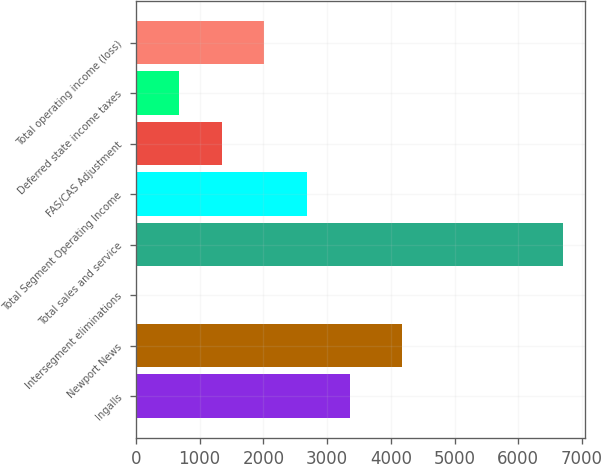<chart> <loc_0><loc_0><loc_500><loc_500><bar_chart><fcel>Ingalls<fcel>Newport News<fcel>Intersegment eliminations<fcel>Total sales and service<fcel>Total Segment Operating Income<fcel>FAS/CAS Adjustment<fcel>Deferred state income taxes<fcel>Total operating income (loss)<nl><fcel>3356<fcel>4180<fcel>4<fcel>6708<fcel>2685.6<fcel>1344.8<fcel>674.4<fcel>2015.2<nl></chart> 